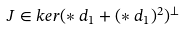Convert formula to latex. <formula><loc_0><loc_0><loc_500><loc_500>J \in k e r ( \ast d _ { 1 } + ( \ast d _ { 1 } ) ^ { 2 } ) ^ { \perp }</formula> 